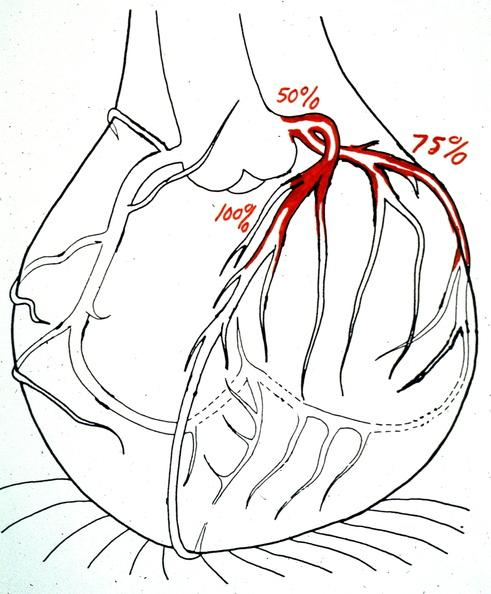s subdiaphragmatic abscess present?
Answer the question using a single word or phrase. No 